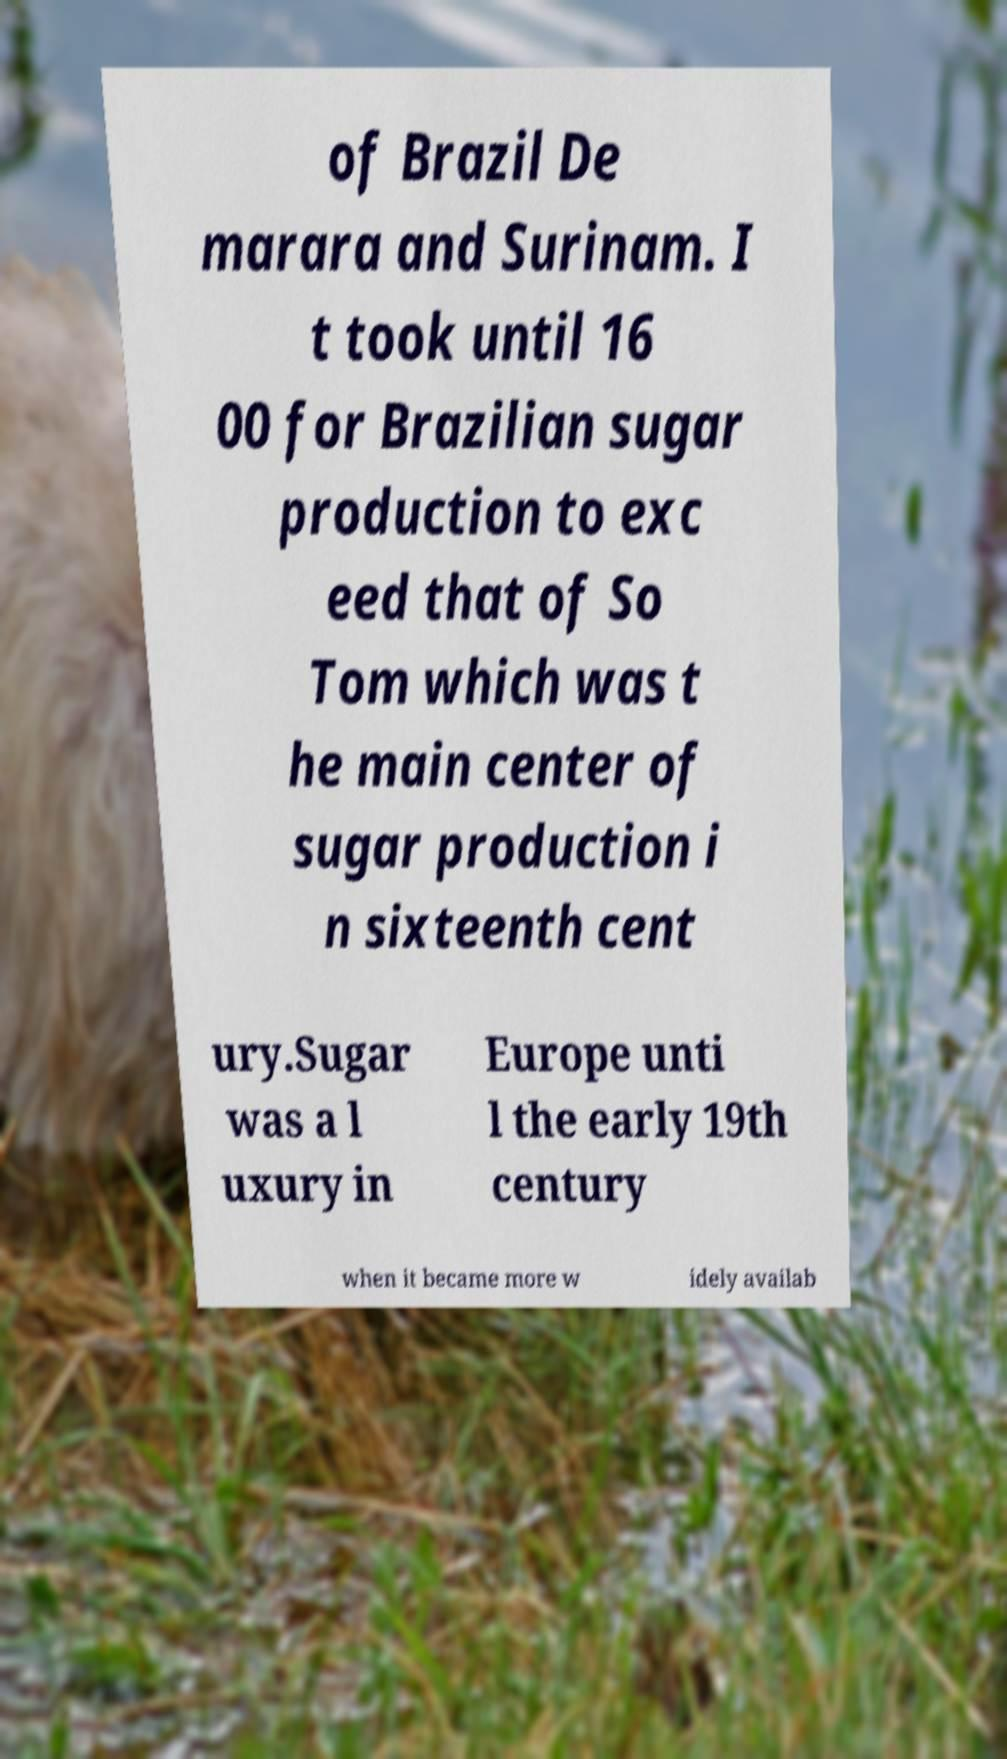For documentation purposes, I need the text within this image transcribed. Could you provide that? of Brazil De marara and Surinam. I t took until 16 00 for Brazilian sugar production to exc eed that of So Tom which was t he main center of sugar production i n sixteenth cent ury.Sugar was a l uxury in Europe unti l the early 19th century when it became more w idely availab 